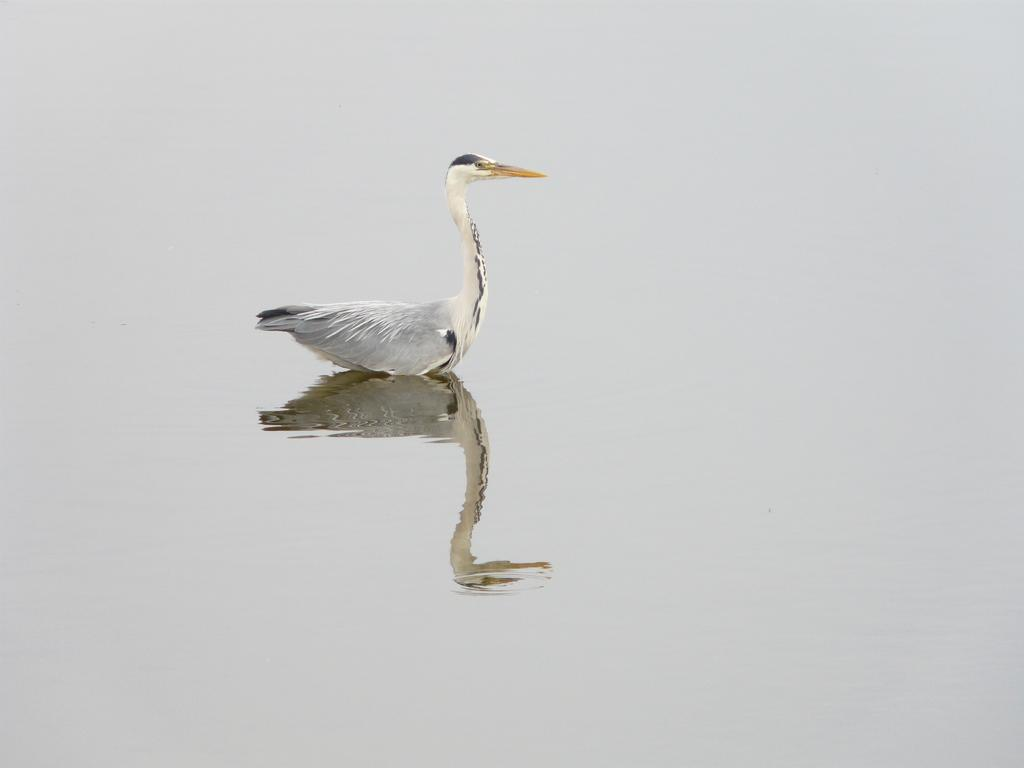What type of animal is in the image? There is a bird in the image. Where is the bird located in the image? The bird is on the surface of the water. What type of root can be seen growing in the water near the bird? There is no root visible in the image; it only features a bird on the surface of the water. 